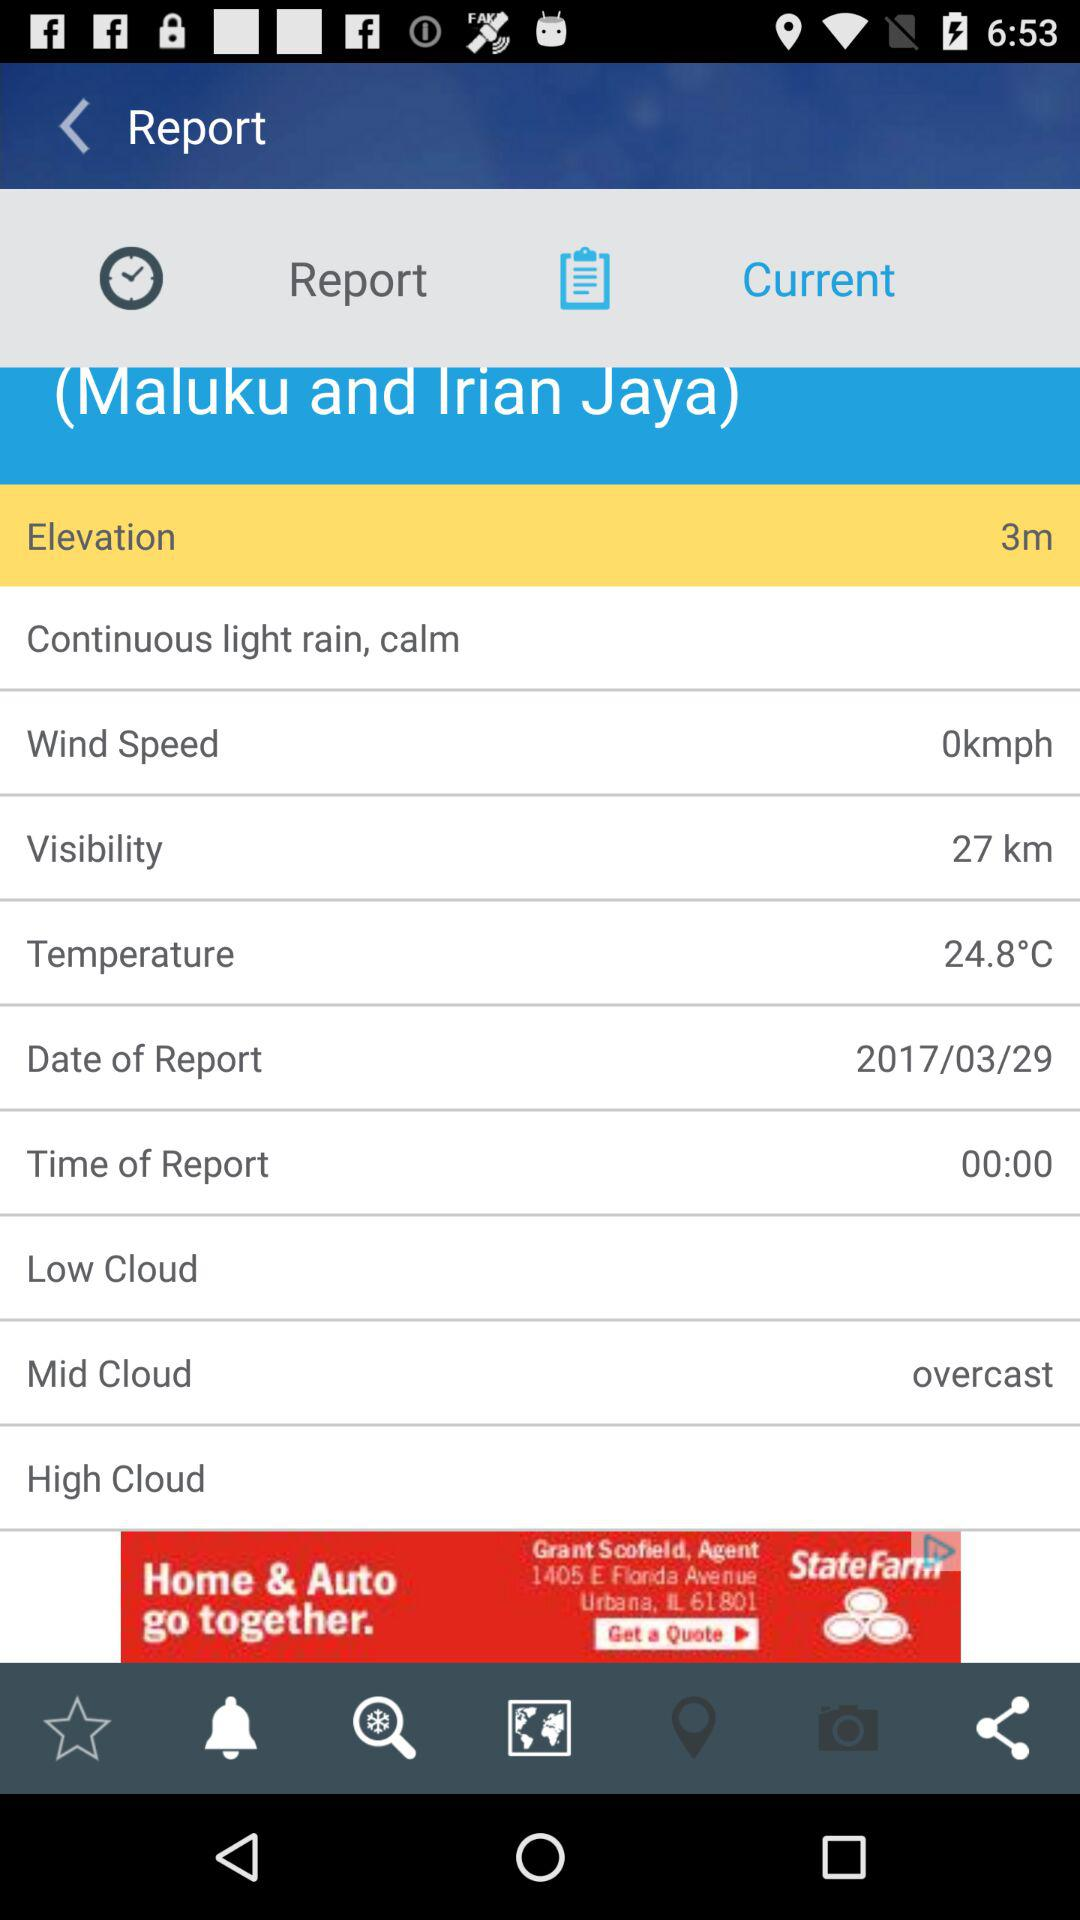What is the visibility? The visibility is 27 km. 